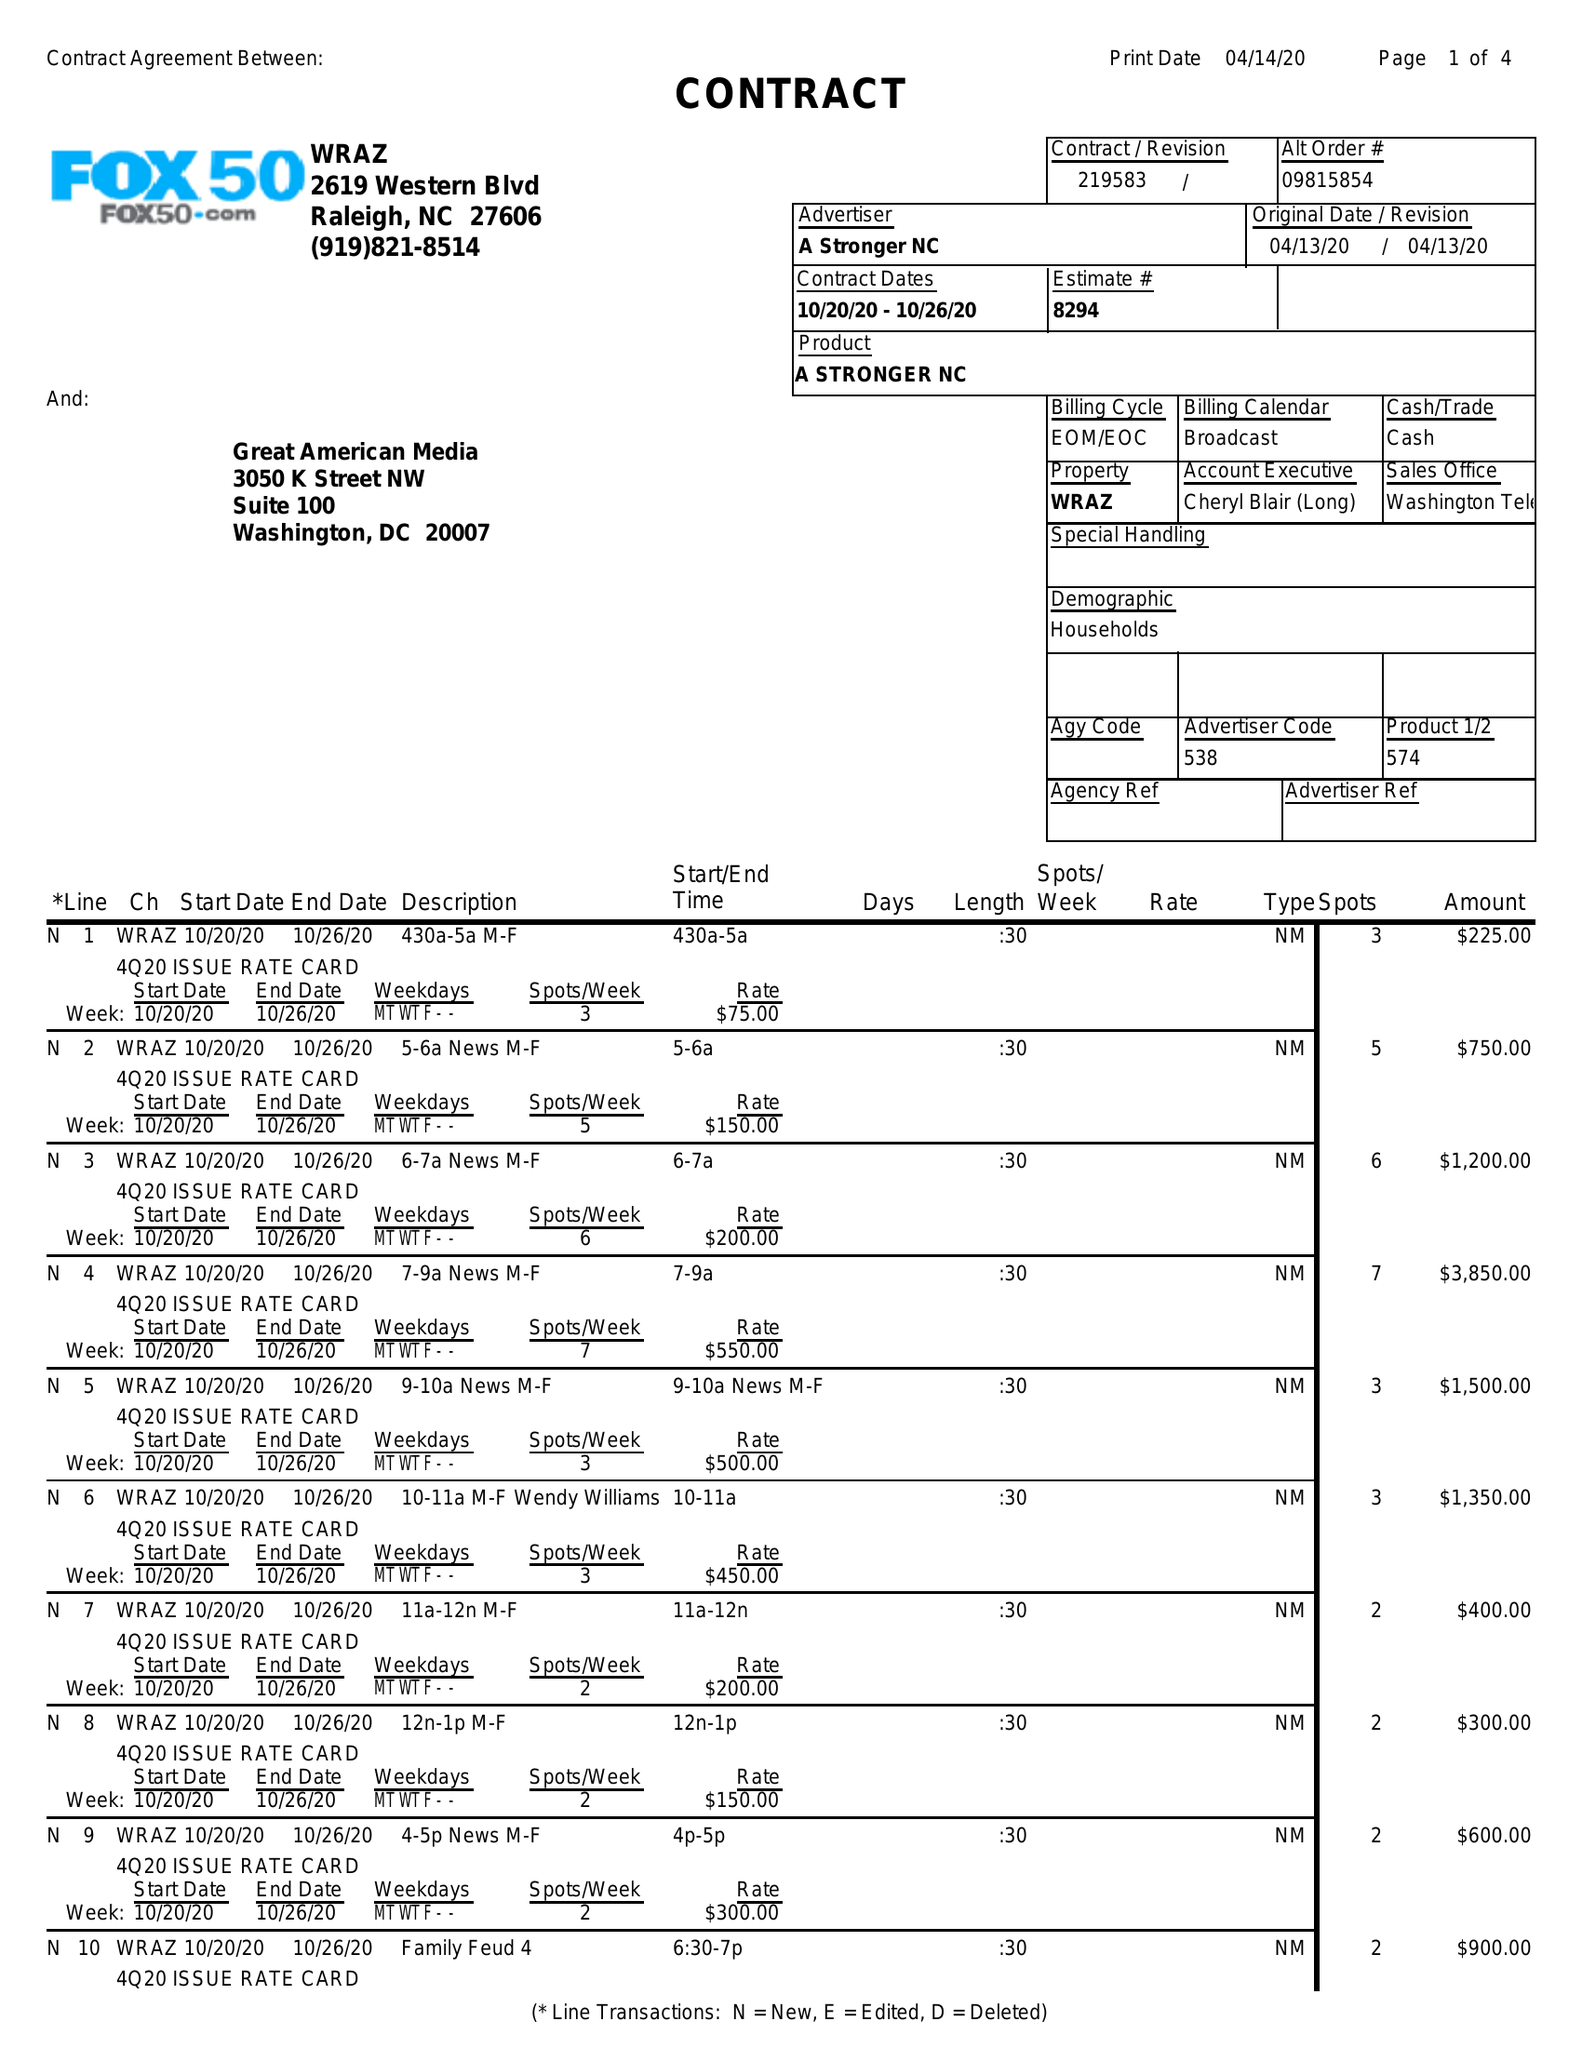What is the value for the flight_from?
Answer the question using a single word or phrase. 10/20/20 